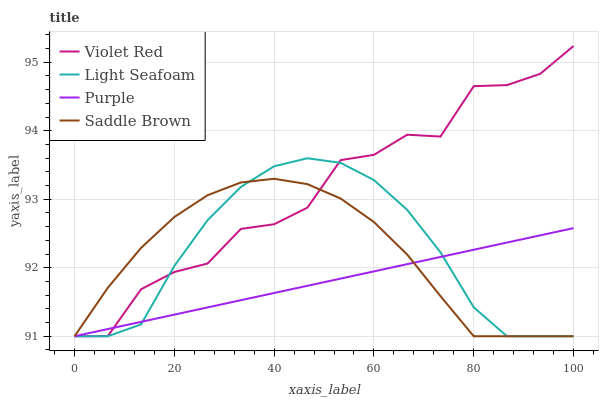Does Purple have the minimum area under the curve?
Answer yes or no. Yes. Does Violet Red have the maximum area under the curve?
Answer yes or no. Yes. Does Light Seafoam have the minimum area under the curve?
Answer yes or no. No. Does Light Seafoam have the maximum area under the curve?
Answer yes or no. No. Is Purple the smoothest?
Answer yes or no. Yes. Is Violet Red the roughest?
Answer yes or no. Yes. Is Light Seafoam the smoothest?
Answer yes or no. No. Is Light Seafoam the roughest?
Answer yes or no. No. Does Purple have the lowest value?
Answer yes or no. Yes. Does Violet Red have the highest value?
Answer yes or no. Yes. Does Light Seafoam have the highest value?
Answer yes or no. No. Does Violet Red intersect Saddle Brown?
Answer yes or no. Yes. Is Violet Red less than Saddle Brown?
Answer yes or no. No. Is Violet Red greater than Saddle Brown?
Answer yes or no. No. 